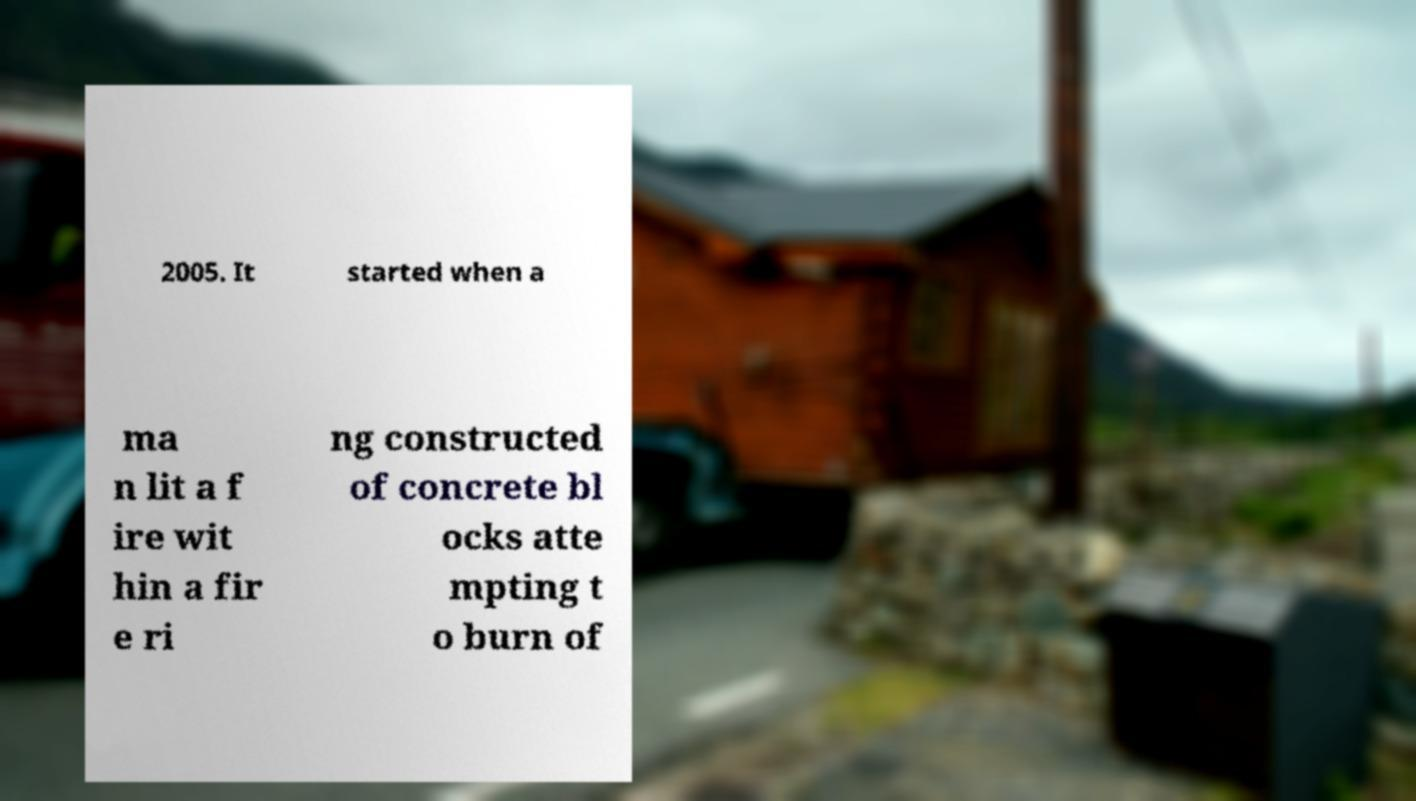I need the written content from this picture converted into text. Can you do that? 2005. It started when a ma n lit a f ire wit hin a fir e ri ng constructed of concrete bl ocks atte mpting t o burn of 